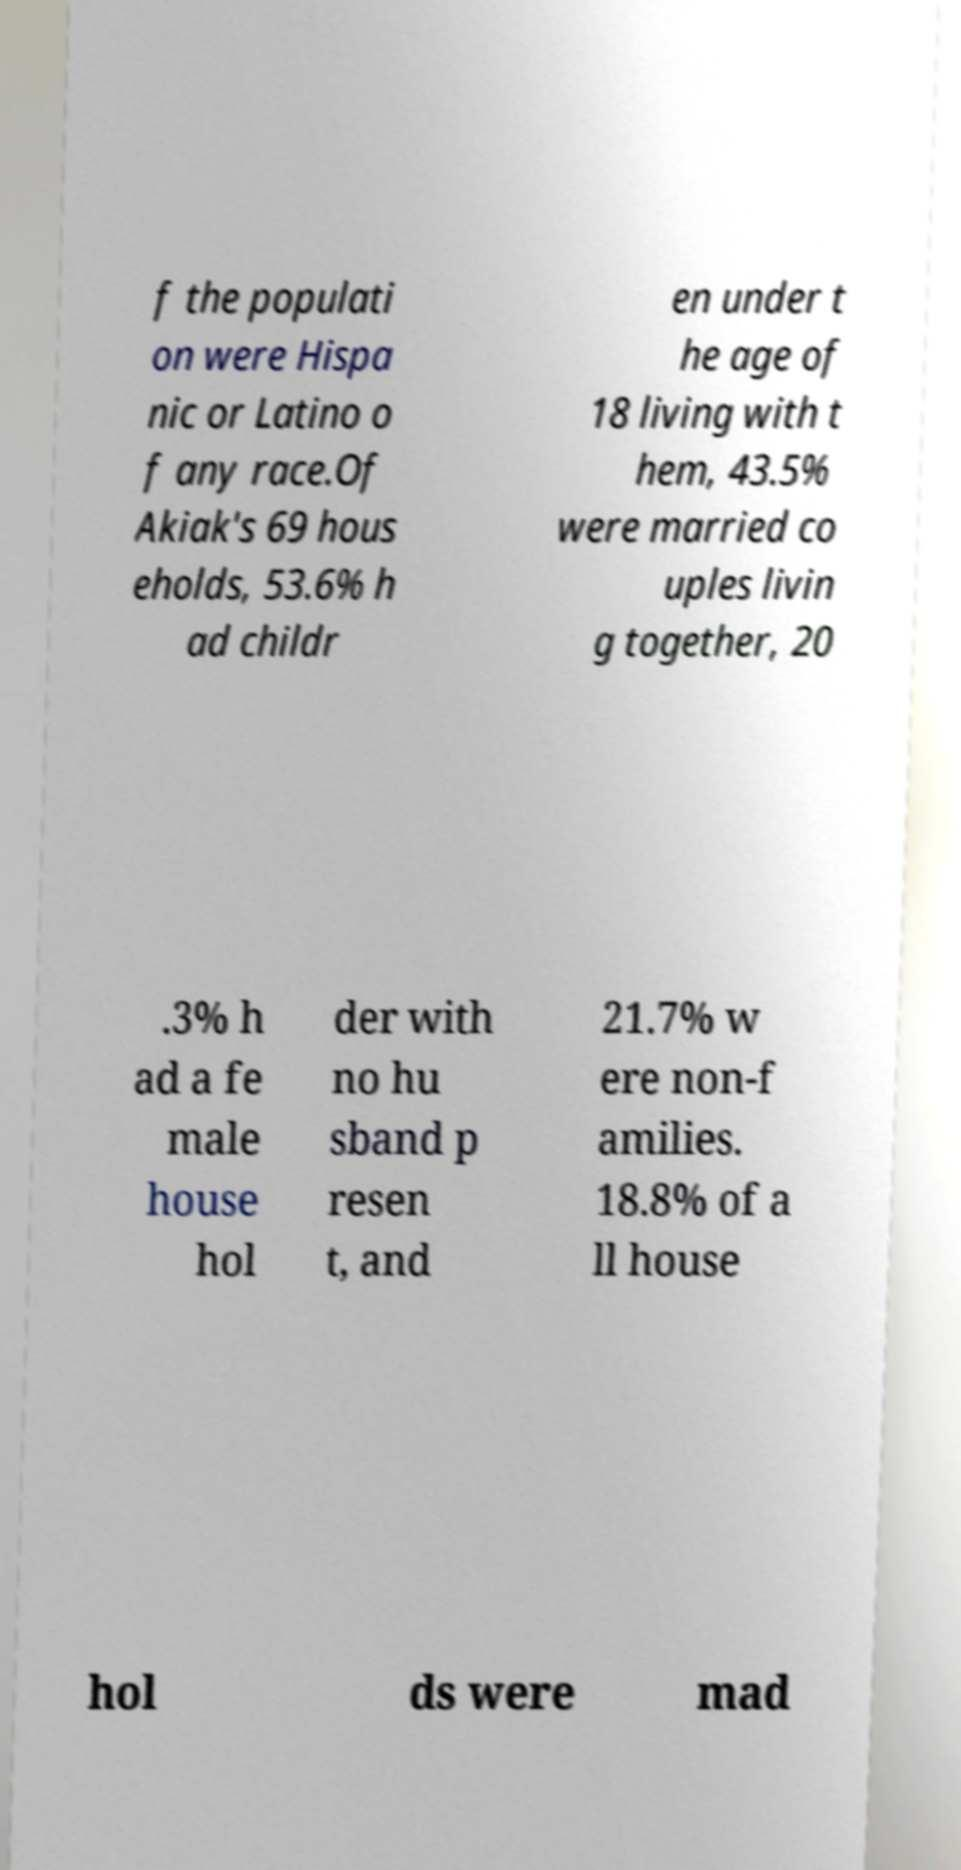Can you read and provide the text displayed in the image?This photo seems to have some interesting text. Can you extract and type it out for me? f the populati on were Hispa nic or Latino o f any race.Of Akiak's 69 hous eholds, 53.6% h ad childr en under t he age of 18 living with t hem, 43.5% were married co uples livin g together, 20 .3% h ad a fe male house hol der with no hu sband p resen t, and 21.7% w ere non-f amilies. 18.8% of a ll house hol ds were mad 